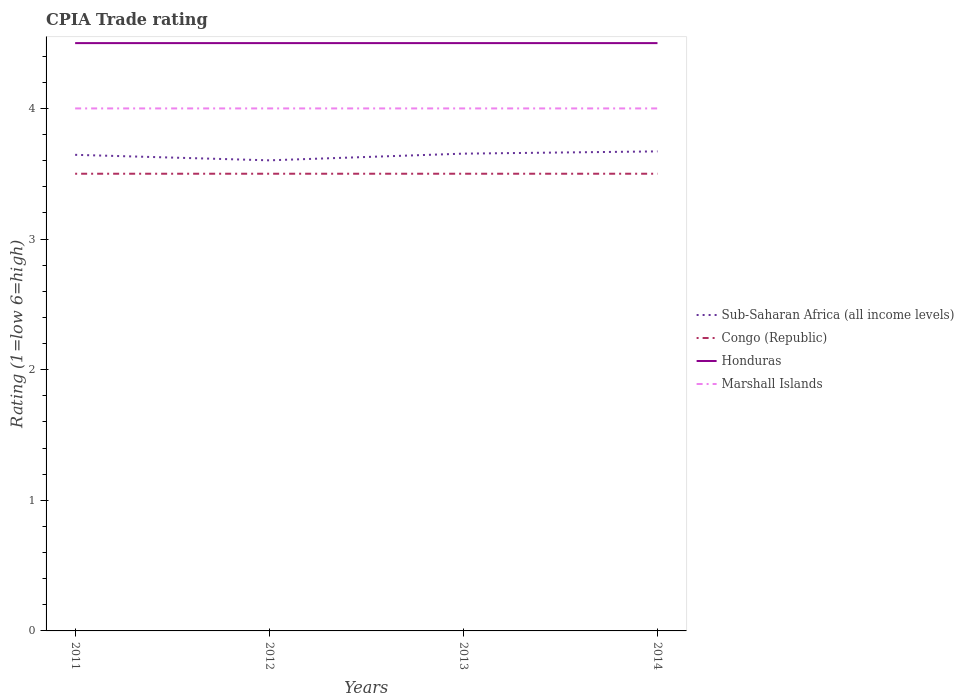Across all years, what is the maximum CPIA rating in Congo (Republic)?
Offer a terse response. 3.5. In which year was the CPIA rating in Sub-Saharan Africa (all income levels) maximum?
Your answer should be compact. 2012. What is the total CPIA rating in Sub-Saharan Africa (all income levels) in the graph?
Offer a terse response. -0.07. What is the difference between two consecutive major ticks on the Y-axis?
Offer a terse response. 1. Are the values on the major ticks of Y-axis written in scientific E-notation?
Ensure brevity in your answer.  No. Does the graph contain any zero values?
Give a very brief answer. No. How many legend labels are there?
Make the answer very short. 4. What is the title of the graph?
Give a very brief answer. CPIA Trade rating. What is the label or title of the Y-axis?
Ensure brevity in your answer.  Rating (1=low 6=high). What is the Rating (1=low 6=high) in Sub-Saharan Africa (all income levels) in 2011?
Keep it short and to the point. 3.64. What is the Rating (1=low 6=high) in Congo (Republic) in 2011?
Your response must be concise. 3.5. What is the Rating (1=low 6=high) in Marshall Islands in 2011?
Offer a very short reply. 4. What is the Rating (1=low 6=high) in Sub-Saharan Africa (all income levels) in 2012?
Make the answer very short. 3.6. What is the Rating (1=low 6=high) of Congo (Republic) in 2012?
Your response must be concise. 3.5. What is the Rating (1=low 6=high) of Honduras in 2012?
Make the answer very short. 4.5. What is the Rating (1=low 6=high) of Marshall Islands in 2012?
Provide a succinct answer. 4. What is the Rating (1=low 6=high) of Sub-Saharan Africa (all income levels) in 2013?
Offer a terse response. 3.65. What is the Rating (1=low 6=high) in Marshall Islands in 2013?
Your answer should be compact. 4. What is the Rating (1=low 6=high) in Sub-Saharan Africa (all income levels) in 2014?
Your answer should be very brief. 3.67. What is the Rating (1=low 6=high) of Congo (Republic) in 2014?
Provide a succinct answer. 3.5. What is the Rating (1=low 6=high) of Marshall Islands in 2014?
Give a very brief answer. 4. Across all years, what is the maximum Rating (1=low 6=high) of Sub-Saharan Africa (all income levels)?
Offer a very short reply. 3.67. Across all years, what is the maximum Rating (1=low 6=high) in Honduras?
Offer a terse response. 4.5. Across all years, what is the minimum Rating (1=low 6=high) of Sub-Saharan Africa (all income levels)?
Give a very brief answer. 3.6. What is the total Rating (1=low 6=high) in Sub-Saharan Africa (all income levels) in the graph?
Offer a terse response. 14.57. What is the total Rating (1=low 6=high) of Congo (Republic) in the graph?
Your response must be concise. 14. What is the total Rating (1=low 6=high) in Honduras in the graph?
Give a very brief answer. 18. What is the difference between the Rating (1=low 6=high) in Sub-Saharan Africa (all income levels) in 2011 and that in 2012?
Keep it short and to the point. 0.04. What is the difference between the Rating (1=low 6=high) in Congo (Republic) in 2011 and that in 2012?
Offer a terse response. 0. What is the difference between the Rating (1=low 6=high) of Sub-Saharan Africa (all income levels) in 2011 and that in 2013?
Keep it short and to the point. -0.01. What is the difference between the Rating (1=low 6=high) in Honduras in 2011 and that in 2013?
Your answer should be very brief. 0. What is the difference between the Rating (1=low 6=high) in Marshall Islands in 2011 and that in 2013?
Your response must be concise. 0. What is the difference between the Rating (1=low 6=high) of Sub-Saharan Africa (all income levels) in 2011 and that in 2014?
Provide a short and direct response. -0.03. What is the difference between the Rating (1=low 6=high) of Honduras in 2011 and that in 2014?
Ensure brevity in your answer.  0. What is the difference between the Rating (1=low 6=high) in Marshall Islands in 2011 and that in 2014?
Your answer should be compact. 0. What is the difference between the Rating (1=low 6=high) in Sub-Saharan Africa (all income levels) in 2012 and that in 2013?
Your answer should be very brief. -0.05. What is the difference between the Rating (1=low 6=high) of Sub-Saharan Africa (all income levels) in 2012 and that in 2014?
Offer a terse response. -0.07. What is the difference between the Rating (1=low 6=high) of Congo (Republic) in 2012 and that in 2014?
Make the answer very short. 0. What is the difference between the Rating (1=low 6=high) of Marshall Islands in 2012 and that in 2014?
Offer a terse response. 0. What is the difference between the Rating (1=low 6=high) in Sub-Saharan Africa (all income levels) in 2013 and that in 2014?
Make the answer very short. -0.02. What is the difference between the Rating (1=low 6=high) in Honduras in 2013 and that in 2014?
Your answer should be very brief. 0. What is the difference between the Rating (1=low 6=high) in Sub-Saharan Africa (all income levels) in 2011 and the Rating (1=low 6=high) in Congo (Republic) in 2012?
Make the answer very short. 0.14. What is the difference between the Rating (1=low 6=high) in Sub-Saharan Africa (all income levels) in 2011 and the Rating (1=low 6=high) in Honduras in 2012?
Your answer should be very brief. -0.86. What is the difference between the Rating (1=low 6=high) of Sub-Saharan Africa (all income levels) in 2011 and the Rating (1=low 6=high) of Marshall Islands in 2012?
Provide a succinct answer. -0.36. What is the difference between the Rating (1=low 6=high) of Congo (Republic) in 2011 and the Rating (1=low 6=high) of Honduras in 2012?
Your answer should be very brief. -1. What is the difference between the Rating (1=low 6=high) of Honduras in 2011 and the Rating (1=low 6=high) of Marshall Islands in 2012?
Keep it short and to the point. 0.5. What is the difference between the Rating (1=low 6=high) in Sub-Saharan Africa (all income levels) in 2011 and the Rating (1=low 6=high) in Congo (Republic) in 2013?
Make the answer very short. 0.14. What is the difference between the Rating (1=low 6=high) of Sub-Saharan Africa (all income levels) in 2011 and the Rating (1=low 6=high) of Honduras in 2013?
Keep it short and to the point. -0.86. What is the difference between the Rating (1=low 6=high) in Sub-Saharan Africa (all income levels) in 2011 and the Rating (1=low 6=high) in Marshall Islands in 2013?
Offer a terse response. -0.36. What is the difference between the Rating (1=low 6=high) of Congo (Republic) in 2011 and the Rating (1=low 6=high) of Honduras in 2013?
Provide a succinct answer. -1. What is the difference between the Rating (1=low 6=high) of Honduras in 2011 and the Rating (1=low 6=high) of Marshall Islands in 2013?
Make the answer very short. 0.5. What is the difference between the Rating (1=low 6=high) in Sub-Saharan Africa (all income levels) in 2011 and the Rating (1=low 6=high) in Congo (Republic) in 2014?
Give a very brief answer. 0.14. What is the difference between the Rating (1=low 6=high) in Sub-Saharan Africa (all income levels) in 2011 and the Rating (1=low 6=high) in Honduras in 2014?
Keep it short and to the point. -0.86. What is the difference between the Rating (1=low 6=high) in Sub-Saharan Africa (all income levels) in 2011 and the Rating (1=low 6=high) in Marshall Islands in 2014?
Ensure brevity in your answer.  -0.36. What is the difference between the Rating (1=low 6=high) in Congo (Republic) in 2011 and the Rating (1=low 6=high) in Honduras in 2014?
Make the answer very short. -1. What is the difference between the Rating (1=low 6=high) in Congo (Republic) in 2011 and the Rating (1=low 6=high) in Marshall Islands in 2014?
Ensure brevity in your answer.  -0.5. What is the difference between the Rating (1=low 6=high) in Honduras in 2011 and the Rating (1=low 6=high) in Marshall Islands in 2014?
Keep it short and to the point. 0.5. What is the difference between the Rating (1=low 6=high) in Sub-Saharan Africa (all income levels) in 2012 and the Rating (1=low 6=high) in Congo (Republic) in 2013?
Provide a succinct answer. 0.1. What is the difference between the Rating (1=low 6=high) of Sub-Saharan Africa (all income levels) in 2012 and the Rating (1=low 6=high) of Honduras in 2013?
Provide a short and direct response. -0.9. What is the difference between the Rating (1=low 6=high) of Sub-Saharan Africa (all income levels) in 2012 and the Rating (1=low 6=high) of Marshall Islands in 2013?
Your response must be concise. -0.4. What is the difference between the Rating (1=low 6=high) in Congo (Republic) in 2012 and the Rating (1=low 6=high) in Marshall Islands in 2013?
Your response must be concise. -0.5. What is the difference between the Rating (1=low 6=high) in Honduras in 2012 and the Rating (1=low 6=high) in Marshall Islands in 2013?
Make the answer very short. 0.5. What is the difference between the Rating (1=low 6=high) of Sub-Saharan Africa (all income levels) in 2012 and the Rating (1=low 6=high) of Congo (Republic) in 2014?
Provide a short and direct response. 0.1. What is the difference between the Rating (1=low 6=high) of Sub-Saharan Africa (all income levels) in 2012 and the Rating (1=low 6=high) of Honduras in 2014?
Your response must be concise. -0.9. What is the difference between the Rating (1=low 6=high) in Sub-Saharan Africa (all income levels) in 2012 and the Rating (1=low 6=high) in Marshall Islands in 2014?
Provide a succinct answer. -0.4. What is the difference between the Rating (1=low 6=high) of Sub-Saharan Africa (all income levels) in 2013 and the Rating (1=low 6=high) of Congo (Republic) in 2014?
Make the answer very short. 0.15. What is the difference between the Rating (1=low 6=high) of Sub-Saharan Africa (all income levels) in 2013 and the Rating (1=low 6=high) of Honduras in 2014?
Offer a terse response. -0.85. What is the difference between the Rating (1=low 6=high) of Sub-Saharan Africa (all income levels) in 2013 and the Rating (1=low 6=high) of Marshall Islands in 2014?
Ensure brevity in your answer.  -0.35. What is the difference between the Rating (1=low 6=high) in Congo (Republic) in 2013 and the Rating (1=low 6=high) in Honduras in 2014?
Keep it short and to the point. -1. What is the difference between the Rating (1=low 6=high) in Congo (Republic) in 2013 and the Rating (1=low 6=high) in Marshall Islands in 2014?
Your answer should be very brief. -0.5. What is the average Rating (1=low 6=high) in Sub-Saharan Africa (all income levels) per year?
Provide a succinct answer. 3.64. What is the average Rating (1=low 6=high) of Congo (Republic) per year?
Provide a short and direct response. 3.5. In the year 2011, what is the difference between the Rating (1=low 6=high) of Sub-Saharan Africa (all income levels) and Rating (1=low 6=high) of Congo (Republic)?
Offer a terse response. 0.14. In the year 2011, what is the difference between the Rating (1=low 6=high) in Sub-Saharan Africa (all income levels) and Rating (1=low 6=high) in Honduras?
Your answer should be compact. -0.86. In the year 2011, what is the difference between the Rating (1=low 6=high) of Sub-Saharan Africa (all income levels) and Rating (1=low 6=high) of Marshall Islands?
Provide a short and direct response. -0.36. In the year 2011, what is the difference between the Rating (1=low 6=high) of Congo (Republic) and Rating (1=low 6=high) of Marshall Islands?
Your answer should be very brief. -0.5. In the year 2011, what is the difference between the Rating (1=low 6=high) in Honduras and Rating (1=low 6=high) in Marshall Islands?
Provide a short and direct response. 0.5. In the year 2012, what is the difference between the Rating (1=low 6=high) of Sub-Saharan Africa (all income levels) and Rating (1=low 6=high) of Congo (Republic)?
Give a very brief answer. 0.1. In the year 2012, what is the difference between the Rating (1=low 6=high) in Sub-Saharan Africa (all income levels) and Rating (1=low 6=high) in Honduras?
Offer a terse response. -0.9. In the year 2012, what is the difference between the Rating (1=low 6=high) in Sub-Saharan Africa (all income levels) and Rating (1=low 6=high) in Marshall Islands?
Keep it short and to the point. -0.4. In the year 2013, what is the difference between the Rating (1=low 6=high) of Sub-Saharan Africa (all income levels) and Rating (1=low 6=high) of Congo (Republic)?
Ensure brevity in your answer.  0.15. In the year 2013, what is the difference between the Rating (1=low 6=high) of Sub-Saharan Africa (all income levels) and Rating (1=low 6=high) of Honduras?
Offer a very short reply. -0.85. In the year 2013, what is the difference between the Rating (1=low 6=high) in Sub-Saharan Africa (all income levels) and Rating (1=low 6=high) in Marshall Islands?
Ensure brevity in your answer.  -0.35. In the year 2013, what is the difference between the Rating (1=low 6=high) of Congo (Republic) and Rating (1=low 6=high) of Honduras?
Offer a very short reply. -1. In the year 2013, what is the difference between the Rating (1=low 6=high) in Honduras and Rating (1=low 6=high) in Marshall Islands?
Offer a very short reply. 0.5. In the year 2014, what is the difference between the Rating (1=low 6=high) of Sub-Saharan Africa (all income levels) and Rating (1=low 6=high) of Congo (Republic)?
Keep it short and to the point. 0.17. In the year 2014, what is the difference between the Rating (1=low 6=high) in Sub-Saharan Africa (all income levels) and Rating (1=low 6=high) in Honduras?
Your answer should be very brief. -0.83. In the year 2014, what is the difference between the Rating (1=low 6=high) in Sub-Saharan Africa (all income levels) and Rating (1=low 6=high) in Marshall Islands?
Make the answer very short. -0.33. In the year 2014, what is the difference between the Rating (1=low 6=high) in Congo (Republic) and Rating (1=low 6=high) in Honduras?
Offer a terse response. -1. In the year 2014, what is the difference between the Rating (1=low 6=high) in Honduras and Rating (1=low 6=high) in Marshall Islands?
Make the answer very short. 0.5. What is the ratio of the Rating (1=low 6=high) in Sub-Saharan Africa (all income levels) in 2011 to that in 2012?
Offer a terse response. 1.01. What is the ratio of the Rating (1=low 6=high) in Congo (Republic) in 2011 to that in 2012?
Give a very brief answer. 1. What is the ratio of the Rating (1=low 6=high) in Honduras in 2011 to that in 2012?
Provide a short and direct response. 1. What is the ratio of the Rating (1=low 6=high) in Sub-Saharan Africa (all income levels) in 2011 to that in 2013?
Your response must be concise. 1. What is the ratio of the Rating (1=low 6=high) in Sub-Saharan Africa (all income levels) in 2011 to that in 2014?
Offer a terse response. 0.99. What is the ratio of the Rating (1=low 6=high) in Sub-Saharan Africa (all income levels) in 2012 to that in 2013?
Ensure brevity in your answer.  0.99. What is the ratio of the Rating (1=low 6=high) of Congo (Republic) in 2012 to that in 2013?
Your answer should be very brief. 1. What is the ratio of the Rating (1=low 6=high) of Honduras in 2012 to that in 2013?
Ensure brevity in your answer.  1. What is the ratio of the Rating (1=low 6=high) in Marshall Islands in 2012 to that in 2013?
Make the answer very short. 1. What is the ratio of the Rating (1=low 6=high) in Sub-Saharan Africa (all income levels) in 2012 to that in 2014?
Keep it short and to the point. 0.98. What is the ratio of the Rating (1=low 6=high) in Congo (Republic) in 2012 to that in 2014?
Keep it short and to the point. 1. What is the ratio of the Rating (1=low 6=high) of Honduras in 2012 to that in 2014?
Your answer should be very brief. 1. What is the ratio of the Rating (1=low 6=high) in Marshall Islands in 2012 to that in 2014?
Provide a short and direct response. 1. What is the ratio of the Rating (1=low 6=high) in Sub-Saharan Africa (all income levels) in 2013 to that in 2014?
Offer a terse response. 1. What is the ratio of the Rating (1=low 6=high) of Congo (Republic) in 2013 to that in 2014?
Give a very brief answer. 1. What is the ratio of the Rating (1=low 6=high) in Honduras in 2013 to that in 2014?
Your answer should be very brief. 1. What is the difference between the highest and the second highest Rating (1=low 6=high) in Sub-Saharan Africa (all income levels)?
Offer a terse response. 0.02. What is the difference between the highest and the second highest Rating (1=low 6=high) in Honduras?
Offer a very short reply. 0. What is the difference between the highest and the lowest Rating (1=low 6=high) in Sub-Saharan Africa (all income levels)?
Provide a short and direct response. 0.07. What is the difference between the highest and the lowest Rating (1=low 6=high) in Honduras?
Ensure brevity in your answer.  0. 